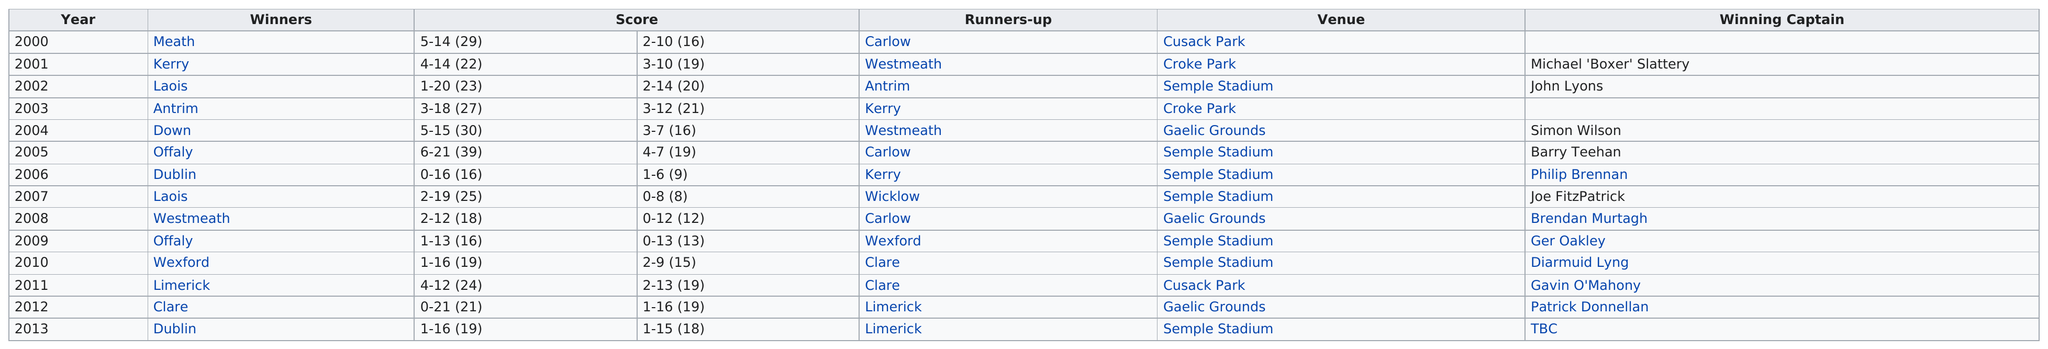Draw attention to some important aspects in this diagram. Wicklow scored the least among all the players. The winner after 2007 was Laois. Michael "Boxer" Slattery was the first winning captain of a Cricket match. In 2000, the scores differed. The runner-up title was held by Carlow for a total of three times. 